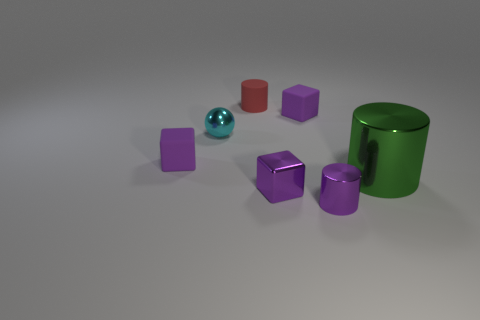Is there anything else that is the same shape as the large green shiny thing?
Your answer should be compact. Yes. There is a purple cube behind the tiny cyan object; are there any purple metallic blocks that are on the right side of it?
Your response must be concise. No. Are there fewer tiny purple matte things that are to the left of the big metal cylinder than cyan spheres in front of the cyan object?
Keep it short and to the point. No. How big is the purple rubber cube that is on the left side of the red object that is behind the matte block that is on the right side of the small red thing?
Your response must be concise. Small. There is a cylinder that is on the left side of the purple shiny cylinder; does it have the same size as the small metallic block?
Your answer should be compact. Yes. How many other objects are there of the same material as the small red cylinder?
Your answer should be very brief. 2. Is the number of large matte blocks greater than the number of small red cylinders?
Provide a succinct answer. No. What is the material of the tiny purple cube that is behind the block that is to the left of the matte cylinder behind the cyan metallic object?
Ensure brevity in your answer.  Rubber. Do the small shiny cylinder and the tiny rubber cylinder have the same color?
Ensure brevity in your answer.  No. Are there any metallic things of the same color as the big shiny cylinder?
Your answer should be very brief. No. 